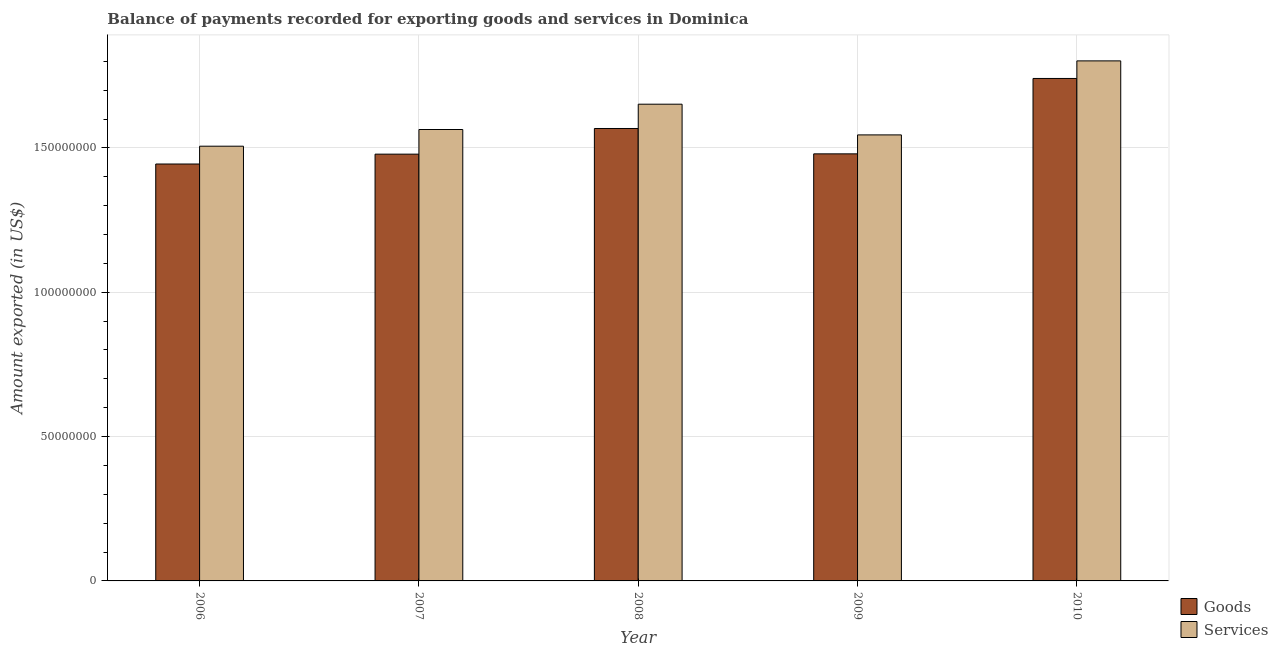Are the number of bars per tick equal to the number of legend labels?
Make the answer very short. Yes. Are the number of bars on each tick of the X-axis equal?
Your response must be concise. Yes. How many bars are there on the 3rd tick from the right?
Offer a very short reply. 2. In how many cases, is the number of bars for a given year not equal to the number of legend labels?
Keep it short and to the point. 0. What is the amount of services exported in 2010?
Give a very brief answer. 1.80e+08. Across all years, what is the maximum amount of services exported?
Your answer should be compact. 1.80e+08. Across all years, what is the minimum amount of services exported?
Ensure brevity in your answer.  1.51e+08. In which year was the amount of services exported minimum?
Give a very brief answer. 2006. What is the total amount of services exported in the graph?
Your answer should be very brief. 8.07e+08. What is the difference between the amount of goods exported in 2006 and that in 2008?
Ensure brevity in your answer.  -1.23e+07. What is the difference between the amount of services exported in 2010 and the amount of goods exported in 2007?
Offer a terse response. 2.38e+07. What is the average amount of services exported per year?
Keep it short and to the point. 1.61e+08. In how many years, is the amount of services exported greater than 80000000 US$?
Offer a very short reply. 5. What is the ratio of the amount of services exported in 2006 to that in 2008?
Offer a very short reply. 0.91. Is the amount of services exported in 2006 less than that in 2009?
Your response must be concise. Yes. What is the difference between the highest and the second highest amount of services exported?
Give a very brief answer. 1.50e+07. What is the difference between the highest and the lowest amount of services exported?
Offer a terse response. 2.96e+07. Is the sum of the amount of goods exported in 2007 and 2010 greater than the maximum amount of services exported across all years?
Offer a terse response. Yes. What does the 1st bar from the left in 2008 represents?
Provide a short and direct response. Goods. What does the 2nd bar from the right in 2009 represents?
Give a very brief answer. Goods. How many years are there in the graph?
Make the answer very short. 5. Does the graph contain grids?
Your response must be concise. Yes. Where does the legend appear in the graph?
Provide a succinct answer. Bottom right. How are the legend labels stacked?
Give a very brief answer. Vertical. What is the title of the graph?
Your response must be concise. Balance of payments recorded for exporting goods and services in Dominica. What is the label or title of the Y-axis?
Provide a succinct answer. Amount exported (in US$). What is the Amount exported (in US$) of Goods in 2006?
Keep it short and to the point. 1.44e+08. What is the Amount exported (in US$) of Services in 2006?
Provide a short and direct response. 1.51e+08. What is the Amount exported (in US$) of Goods in 2007?
Your answer should be compact. 1.48e+08. What is the Amount exported (in US$) in Services in 2007?
Provide a succinct answer. 1.56e+08. What is the Amount exported (in US$) in Goods in 2008?
Keep it short and to the point. 1.57e+08. What is the Amount exported (in US$) of Services in 2008?
Give a very brief answer. 1.65e+08. What is the Amount exported (in US$) in Goods in 2009?
Your response must be concise. 1.48e+08. What is the Amount exported (in US$) of Services in 2009?
Your answer should be very brief. 1.55e+08. What is the Amount exported (in US$) of Goods in 2010?
Keep it short and to the point. 1.74e+08. What is the Amount exported (in US$) in Services in 2010?
Your answer should be very brief. 1.80e+08. Across all years, what is the maximum Amount exported (in US$) of Goods?
Keep it short and to the point. 1.74e+08. Across all years, what is the maximum Amount exported (in US$) in Services?
Provide a short and direct response. 1.80e+08. Across all years, what is the minimum Amount exported (in US$) in Goods?
Offer a terse response. 1.44e+08. Across all years, what is the minimum Amount exported (in US$) of Services?
Provide a succinct answer. 1.51e+08. What is the total Amount exported (in US$) of Goods in the graph?
Your answer should be compact. 7.71e+08. What is the total Amount exported (in US$) of Services in the graph?
Give a very brief answer. 8.07e+08. What is the difference between the Amount exported (in US$) of Goods in 2006 and that in 2007?
Offer a very short reply. -3.41e+06. What is the difference between the Amount exported (in US$) of Services in 2006 and that in 2007?
Your response must be concise. -5.78e+06. What is the difference between the Amount exported (in US$) in Goods in 2006 and that in 2008?
Ensure brevity in your answer.  -1.23e+07. What is the difference between the Amount exported (in US$) of Services in 2006 and that in 2008?
Provide a short and direct response. -1.46e+07. What is the difference between the Amount exported (in US$) in Goods in 2006 and that in 2009?
Ensure brevity in your answer.  -3.52e+06. What is the difference between the Amount exported (in US$) in Services in 2006 and that in 2009?
Your response must be concise. -3.92e+06. What is the difference between the Amount exported (in US$) in Goods in 2006 and that in 2010?
Keep it short and to the point. -2.96e+07. What is the difference between the Amount exported (in US$) of Services in 2006 and that in 2010?
Ensure brevity in your answer.  -2.96e+07. What is the difference between the Amount exported (in US$) in Goods in 2007 and that in 2008?
Your answer should be compact. -8.89e+06. What is the difference between the Amount exported (in US$) in Services in 2007 and that in 2008?
Offer a very short reply. -8.77e+06. What is the difference between the Amount exported (in US$) in Goods in 2007 and that in 2009?
Offer a very short reply. -1.05e+05. What is the difference between the Amount exported (in US$) of Services in 2007 and that in 2009?
Offer a very short reply. 1.87e+06. What is the difference between the Amount exported (in US$) of Goods in 2007 and that in 2010?
Keep it short and to the point. -2.62e+07. What is the difference between the Amount exported (in US$) of Services in 2007 and that in 2010?
Ensure brevity in your answer.  -2.38e+07. What is the difference between the Amount exported (in US$) in Goods in 2008 and that in 2009?
Offer a terse response. 8.78e+06. What is the difference between the Amount exported (in US$) of Services in 2008 and that in 2009?
Your answer should be compact. 1.06e+07. What is the difference between the Amount exported (in US$) of Goods in 2008 and that in 2010?
Keep it short and to the point. -1.73e+07. What is the difference between the Amount exported (in US$) in Services in 2008 and that in 2010?
Offer a terse response. -1.50e+07. What is the difference between the Amount exported (in US$) of Goods in 2009 and that in 2010?
Provide a short and direct response. -2.61e+07. What is the difference between the Amount exported (in US$) in Services in 2009 and that in 2010?
Offer a terse response. -2.56e+07. What is the difference between the Amount exported (in US$) of Goods in 2006 and the Amount exported (in US$) of Services in 2007?
Give a very brief answer. -1.20e+07. What is the difference between the Amount exported (in US$) in Goods in 2006 and the Amount exported (in US$) in Services in 2008?
Your response must be concise. -2.07e+07. What is the difference between the Amount exported (in US$) in Goods in 2006 and the Amount exported (in US$) in Services in 2009?
Provide a short and direct response. -1.01e+07. What is the difference between the Amount exported (in US$) of Goods in 2006 and the Amount exported (in US$) of Services in 2010?
Keep it short and to the point. -3.57e+07. What is the difference between the Amount exported (in US$) in Goods in 2007 and the Amount exported (in US$) in Services in 2008?
Your answer should be compact. -1.73e+07. What is the difference between the Amount exported (in US$) in Goods in 2007 and the Amount exported (in US$) in Services in 2009?
Provide a short and direct response. -6.67e+06. What is the difference between the Amount exported (in US$) of Goods in 2007 and the Amount exported (in US$) of Services in 2010?
Provide a short and direct response. -3.23e+07. What is the difference between the Amount exported (in US$) of Goods in 2008 and the Amount exported (in US$) of Services in 2009?
Offer a terse response. 2.22e+06. What is the difference between the Amount exported (in US$) in Goods in 2008 and the Amount exported (in US$) in Services in 2010?
Offer a terse response. -2.34e+07. What is the difference between the Amount exported (in US$) in Goods in 2009 and the Amount exported (in US$) in Services in 2010?
Keep it short and to the point. -3.22e+07. What is the average Amount exported (in US$) of Goods per year?
Offer a terse response. 1.54e+08. What is the average Amount exported (in US$) in Services per year?
Provide a succinct answer. 1.61e+08. In the year 2006, what is the difference between the Amount exported (in US$) in Goods and Amount exported (in US$) in Services?
Ensure brevity in your answer.  -6.17e+06. In the year 2007, what is the difference between the Amount exported (in US$) in Goods and Amount exported (in US$) in Services?
Provide a short and direct response. -8.54e+06. In the year 2008, what is the difference between the Amount exported (in US$) of Goods and Amount exported (in US$) of Services?
Provide a short and direct response. -8.42e+06. In the year 2009, what is the difference between the Amount exported (in US$) of Goods and Amount exported (in US$) of Services?
Offer a very short reply. -6.57e+06. In the year 2010, what is the difference between the Amount exported (in US$) in Goods and Amount exported (in US$) in Services?
Your response must be concise. -6.09e+06. What is the ratio of the Amount exported (in US$) in Goods in 2006 to that in 2007?
Offer a very short reply. 0.98. What is the ratio of the Amount exported (in US$) in Services in 2006 to that in 2007?
Your answer should be compact. 0.96. What is the ratio of the Amount exported (in US$) of Goods in 2006 to that in 2008?
Your answer should be compact. 0.92. What is the ratio of the Amount exported (in US$) of Services in 2006 to that in 2008?
Your answer should be very brief. 0.91. What is the ratio of the Amount exported (in US$) of Goods in 2006 to that in 2009?
Your answer should be compact. 0.98. What is the ratio of the Amount exported (in US$) of Services in 2006 to that in 2009?
Ensure brevity in your answer.  0.97. What is the ratio of the Amount exported (in US$) in Goods in 2006 to that in 2010?
Make the answer very short. 0.83. What is the ratio of the Amount exported (in US$) of Services in 2006 to that in 2010?
Give a very brief answer. 0.84. What is the ratio of the Amount exported (in US$) in Goods in 2007 to that in 2008?
Keep it short and to the point. 0.94. What is the ratio of the Amount exported (in US$) of Services in 2007 to that in 2008?
Provide a succinct answer. 0.95. What is the ratio of the Amount exported (in US$) of Services in 2007 to that in 2009?
Keep it short and to the point. 1.01. What is the ratio of the Amount exported (in US$) in Goods in 2007 to that in 2010?
Keep it short and to the point. 0.85. What is the ratio of the Amount exported (in US$) of Services in 2007 to that in 2010?
Your answer should be very brief. 0.87. What is the ratio of the Amount exported (in US$) in Goods in 2008 to that in 2009?
Give a very brief answer. 1.06. What is the ratio of the Amount exported (in US$) of Services in 2008 to that in 2009?
Ensure brevity in your answer.  1.07. What is the ratio of the Amount exported (in US$) of Goods in 2008 to that in 2010?
Provide a short and direct response. 0.9. What is the ratio of the Amount exported (in US$) in Services in 2008 to that in 2010?
Keep it short and to the point. 0.92. What is the ratio of the Amount exported (in US$) in Services in 2009 to that in 2010?
Keep it short and to the point. 0.86. What is the difference between the highest and the second highest Amount exported (in US$) of Goods?
Offer a very short reply. 1.73e+07. What is the difference between the highest and the second highest Amount exported (in US$) of Services?
Offer a terse response. 1.50e+07. What is the difference between the highest and the lowest Amount exported (in US$) of Goods?
Ensure brevity in your answer.  2.96e+07. What is the difference between the highest and the lowest Amount exported (in US$) in Services?
Give a very brief answer. 2.96e+07. 